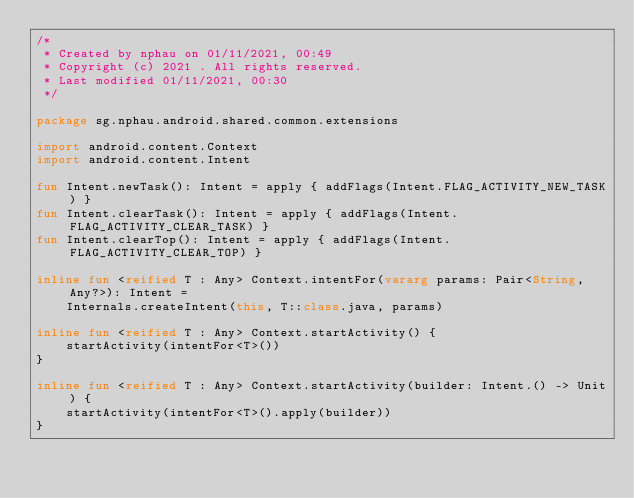<code> <loc_0><loc_0><loc_500><loc_500><_Kotlin_>/*
 * Created by nphau on 01/11/2021, 00:49
 * Copyright (c) 2021 . All rights reserved.
 * Last modified 01/11/2021, 00:30
 */

package sg.nphau.android.shared.common.extensions

import android.content.Context
import android.content.Intent

fun Intent.newTask(): Intent = apply { addFlags(Intent.FLAG_ACTIVITY_NEW_TASK) }
fun Intent.clearTask(): Intent = apply { addFlags(Intent.FLAG_ACTIVITY_CLEAR_TASK) }
fun Intent.clearTop(): Intent = apply { addFlags(Intent.FLAG_ACTIVITY_CLEAR_TOP) }

inline fun <reified T : Any> Context.intentFor(vararg params: Pair<String, Any?>): Intent =
    Internals.createIntent(this, T::class.java, params)

inline fun <reified T : Any> Context.startActivity() {
    startActivity(intentFor<T>())
}

inline fun <reified T : Any> Context.startActivity(builder: Intent.() -> Unit) {
    startActivity(intentFor<T>().apply(builder))
}</code> 